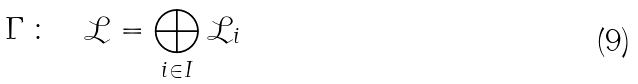Convert formula to latex. <formula><loc_0><loc_0><loc_500><loc_500>\Gamma \, \colon \quad \mathcal { L } = \bigoplus _ { i \in I } { \mathcal { L } } _ { i }</formula> 